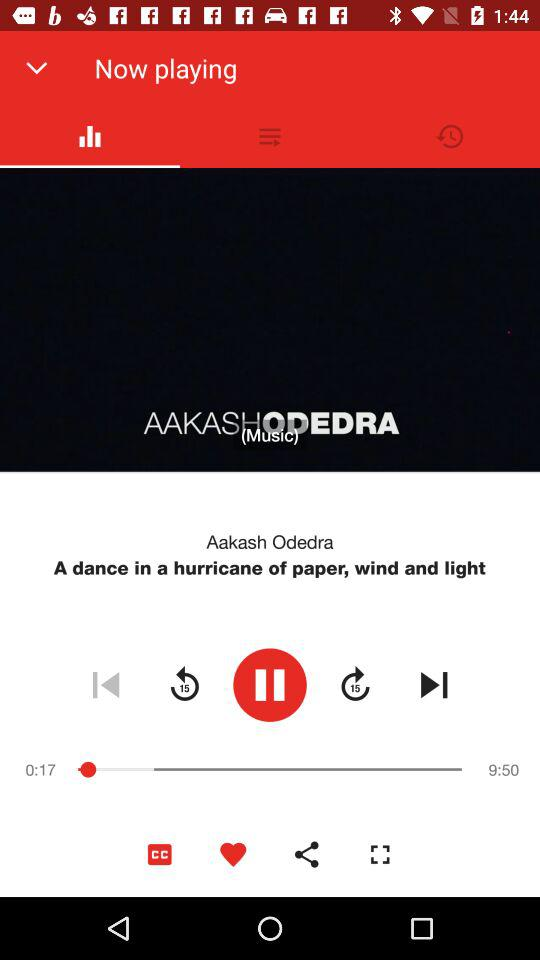How long has the video been playing for?
Answer the question using a single word or phrase. 0:17 